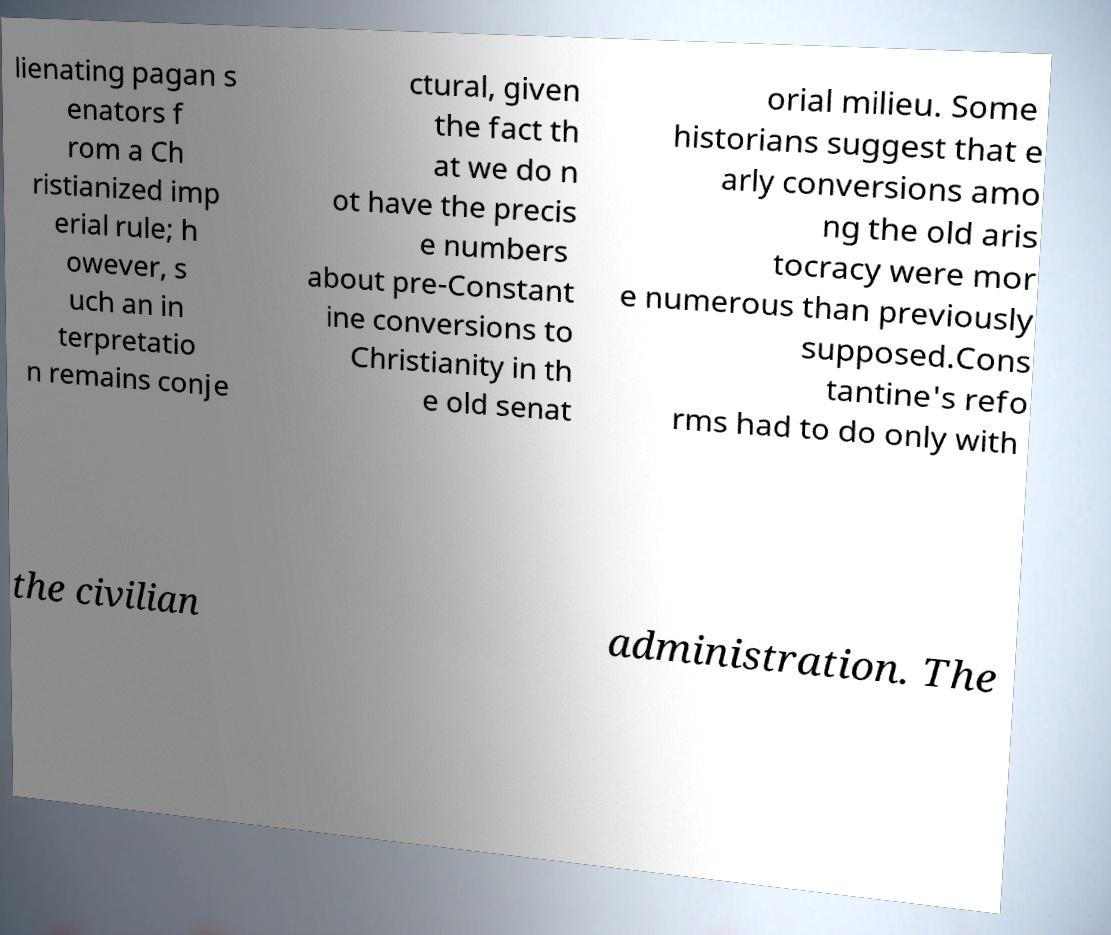Please read and relay the text visible in this image. What does it say? lienating pagan s enators f rom a Ch ristianized imp erial rule; h owever, s uch an in terpretatio n remains conje ctural, given the fact th at we do n ot have the precis e numbers about pre-Constant ine conversions to Christianity in th e old senat orial milieu. Some historians suggest that e arly conversions amo ng the old aris tocracy were mor e numerous than previously supposed.Cons tantine's refo rms had to do only with the civilian administration. The 